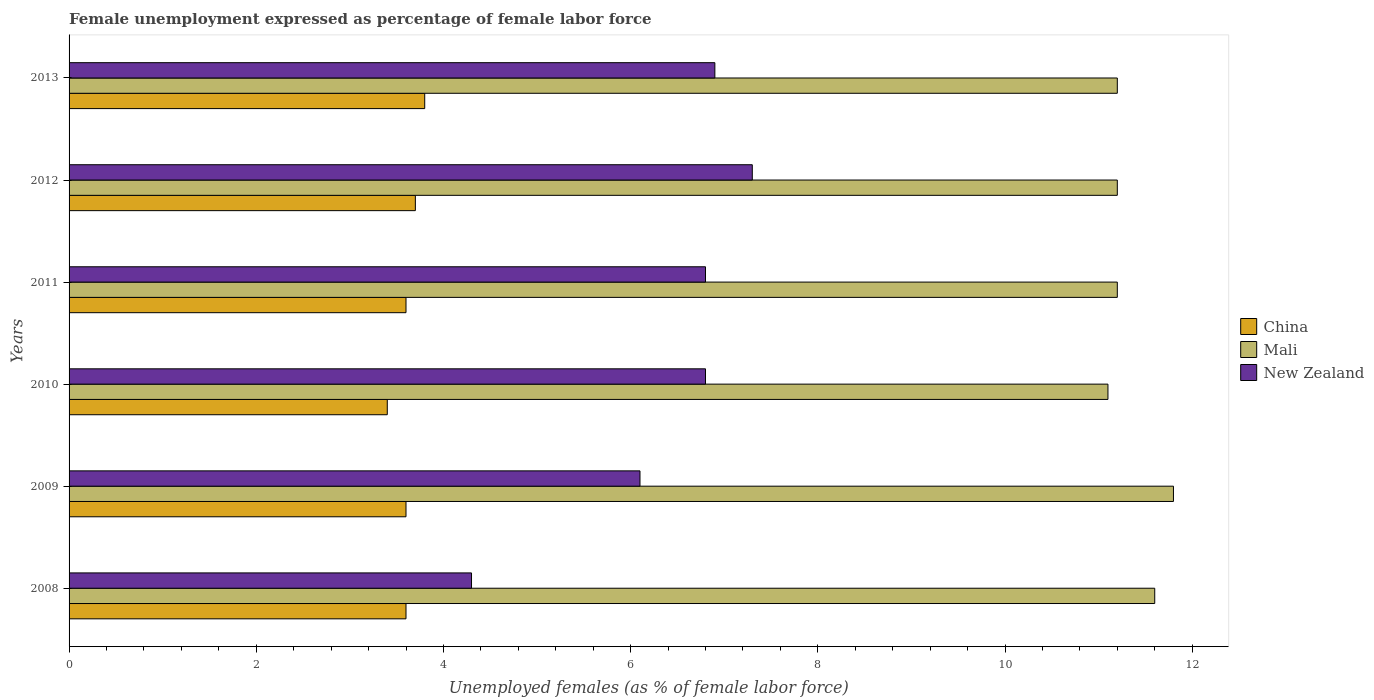Are the number of bars per tick equal to the number of legend labels?
Your answer should be compact. Yes. How many bars are there on the 2nd tick from the bottom?
Offer a very short reply. 3. What is the label of the 4th group of bars from the top?
Your response must be concise. 2010. In how many cases, is the number of bars for a given year not equal to the number of legend labels?
Keep it short and to the point. 0. What is the unemployment in females in in New Zealand in 2010?
Your answer should be very brief. 6.8. Across all years, what is the maximum unemployment in females in in China?
Provide a succinct answer. 3.8. Across all years, what is the minimum unemployment in females in in New Zealand?
Your answer should be compact. 4.3. In which year was the unemployment in females in in Mali minimum?
Provide a succinct answer. 2010. What is the total unemployment in females in in Mali in the graph?
Keep it short and to the point. 68.1. What is the difference between the unemployment in females in in China in 2012 and that in 2013?
Provide a short and direct response. -0.1. What is the difference between the unemployment in females in in New Zealand in 2010 and the unemployment in females in in China in 2013?
Ensure brevity in your answer.  3. What is the average unemployment in females in in China per year?
Give a very brief answer. 3.62. In the year 2012, what is the difference between the unemployment in females in in China and unemployment in females in in New Zealand?
Ensure brevity in your answer.  -3.6. What is the ratio of the unemployment in females in in Mali in 2009 to that in 2013?
Provide a short and direct response. 1.05. Is the difference between the unemployment in females in in China in 2010 and 2013 greater than the difference between the unemployment in females in in New Zealand in 2010 and 2013?
Make the answer very short. No. What is the difference between the highest and the second highest unemployment in females in in New Zealand?
Provide a short and direct response. 0.4. What is the difference between the highest and the lowest unemployment in females in in China?
Ensure brevity in your answer.  0.4. What does the 1st bar from the top in 2008 represents?
Your response must be concise. New Zealand. What does the 2nd bar from the bottom in 2011 represents?
Ensure brevity in your answer.  Mali. Are the values on the major ticks of X-axis written in scientific E-notation?
Give a very brief answer. No. Does the graph contain grids?
Make the answer very short. No. How many legend labels are there?
Your response must be concise. 3. What is the title of the graph?
Your response must be concise. Female unemployment expressed as percentage of female labor force. What is the label or title of the X-axis?
Give a very brief answer. Unemployed females (as % of female labor force). What is the Unemployed females (as % of female labor force) of China in 2008?
Give a very brief answer. 3.6. What is the Unemployed females (as % of female labor force) of Mali in 2008?
Offer a very short reply. 11.6. What is the Unemployed females (as % of female labor force) of New Zealand in 2008?
Offer a terse response. 4.3. What is the Unemployed females (as % of female labor force) of China in 2009?
Keep it short and to the point. 3.6. What is the Unemployed females (as % of female labor force) of Mali in 2009?
Give a very brief answer. 11.8. What is the Unemployed females (as % of female labor force) of New Zealand in 2009?
Keep it short and to the point. 6.1. What is the Unemployed females (as % of female labor force) in China in 2010?
Make the answer very short. 3.4. What is the Unemployed females (as % of female labor force) in Mali in 2010?
Offer a terse response. 11.1. What is the Unemployed females (as % of female labor force) in New Zealand in 2010?
Your answer should be compact. 6.8. What is the Unemployed females (as % of female labor force) in China in 2011?
Your answer should be compact. 3.6. What is the Unemployed females (as % of female labor force) in Mali in 2011?
Provide a short and direct response. 11.2. What is the Unemployed females (as % of female labor force) of New Zealand in 2011?
Provide a succinct answer. 6.8. What is the Unemployed females (as % of female labor force) in China in 2012?
Offer a terse response. 3.7. What is the Unemployed females (as % of female labor force) of Mali in 2012?
Your answer should be very brief. 11.2. What is the Unemployed females (as % of female labor force) in New Zealand in 2012?
Your response must be concise. 7.3. What is the Unemployed females (as % of female labor force) in China in 2013?
Provide a succinct answer. 3.8. What is the Unemployed females (as % of female labor force) of Mali in 2013?
Provide a succinct answer. 11.2. What is the Unemployed females (as % of female labor force) in New Zealand in 2013?
Offer a terse response. 6.9. Across all years, what is the maximum Unemployed females (as % of female labor force) in China?
Give a very brief answer. 3.8. Across all years, what is the maximum Unemployed females (as % of female labor force) of Mali?
Give a very brief answer. 11.8. Across all years, what is the maximum Unemployed females (as % of female labor force) in New Zealand?
Ensure brevity in your answer.  7.3. Across all years, what is the minimum Unemployed females (as % of female labor force) in China?
Provide a succinct answer. 3.4. Across all years, what is the minimum Unemployed females (as % of female labor force) of Mali?
Ensure brevity in your answer.  11.1. Across all years, what is the minimum Unemployed females (as % of female labor force) of New Zealand?
Ensure brevity in your answer.  4.3. What is the total Unemployed females (as % of female labor force) of China in the graph?
Your answer should be compact. 21.7. What is the total Unemployed females (as % of female labor force) of Mali in the graph?
Your response must be concise. 68.1. What is the total Unemployed females (as % of female labor force) of New Zealand in the graph?
Keep it short and to the point. 38.2. What is the difference between the Unemployed females (as % of female labor force) in New Zealand in 2008 and that in 2009?
Provide a succinct answer. -1.8. What is the difference between the Unemployed females (as % of female labor force) of China in 2008 and that in 2011?
Offer a terse response. 0. What is the difference between the Unemployed females (as % of female labor force) in China in 2008 and that in 2012?
Provide a succinct answer. -0.1. What is the difference between the Unemployed females (as % of female labor force) of Mali in 2008 and that in 2012?
Ensure brevity in your answer.  0.4. What is the difference between the Unemployed females (as % of female labor force) of China in 2008 and that in 2013?
Make the answer very short. -0.2. What is the difference between the Unemployed females (as % of female labor force) of Mali in 2008 and that in 2013?
Give a very brief answer. 0.4. What is the difference between the Unemployed females (as % of female labor force) in New Zealand in 2009 and that in 2010?
Your answer should be compact. -0.7. What is the difference between the Unemployed females (as % of female labor force) in Mali in 2009 and that in 2011?
Your response must be concise. 0.6. What is the difference between the Unemployed females (as % of female labor force) of China in 2009 and that in 2012?
Your answer should be compact. -0.1. What is the difference between the Unemployed females (as % of female labor force) in Mali in 2009 and that in 2012?
Provide a succinct answer. 0.6. What is the difference between the Unemployed females (as % of female labor force) in China in 2009 and that in 2013?
Make the answer very short. -0.2. What is the difference between the Unemployed females (as % of female labor force) in Mali in 2009 and that in 2013?
Make the answer very short. 0.6. What is the difference between the Unemployed females (as % of female labor force) in China in 2010 and that in 2011?
Keep it short and to the point. -0.2. What is the difference between the Unemployed females (as % of female labor force) of Mali in 2010 and that in 2011?
Give a very brief answer. -0.1. What is the difference between the Unemployed females (as % of female labor force) of Mali in 2010 and that in 2012?
Your answer should be very brief. -0.1. What is the difference between the Unemployed females (as % of female labor force) in New Zealand in 2010 and that in 2012?
Provide a short and direct response. -0.5. What is the difference between the Unemployed females (as % of female labor force) in New Zealand in 2010 and that in 2013?
Offer a terse response. -0.1. What is the difference between the Unemployed females (as % of female labor force) of China in 2011 and that in 2013?
Ensure brevity in your answer.  -0.2. What is the difference between the Unemployed females (as % of female labor force) in New Zealand in 2011 and that in 2013?
Your answer should be very brief. -0.1. What is the difference between the Unemployed females (as % of female labor force) of China in 2012 and that in 2013?
Provide a short and direct response. -0.1. What is the difference between the Unemployed females (as % of female labor force) of New Zealand in 2012 and that in 2013?
Your response must be concise. 0.4. What is the difference between the Unemployed females (as % of female labor force) in China in 2008 and the Unemployed females (as % of female labor force) in New Zealand in 2009?
Your answer should be very brief. -2.5. What is the difference between the Unemployed females (as % of female labor force) of Mali in 2008 and the Unemployed females (as % of female labor force) of New Zealand in 2009?
Keep it short and to the point. 5.5. What is the difference between the Unemployed females (as % of female labor force) of China in 2008 and the Unemployed females (as % of female labor force) of Mali in 2010?
Your response must be concise. -7.5. What is the difference between the Unemployed females (as % of female labor force) in Mali in 2008 and the Unemployed females (as % of female labor force) in New Zealand in 2010?
Your response must be concise. 4.8. What is the difference between the Unemployed females (as % of female labor force) of China in 2008 and the Unemployed females (as % of female labor force) of Mali in 2011?
Provide a succinct answer. -7.6. What is the difference between the Unemployed females (as % of female labor force) in China in 2008 and the Unemployed females (as % of female labor force) in New Zealand in 2011?
Your answer should be very brief. -3.2. What is the difference between the Unemployed females (as % of female labor force) of China in 2008 and the Unemployed females (as % of female labor force) of New Zealand in 2013?
Your answer should be very brief. -3.3. What is the difference between the Unemployed females (as % of female labor force) of Mali in 2008 and the Unemployed females (as % of female labor force) of New Zealand in 2013?
Your answer should be very brief. 4.7. What is the difference between the Unemployed females (as % of female labor force) in China in 2009 and the Unemployed females (as % of female labor force) in Mali in 2010?
Your response must be concise. -7.5. What is the difference between the Unemployed females (as % of female labor force) of China in 2009 and the Unemployed females (as % of female labor force) of Mali in 2011?
Keep it short and to the point. -7.6. What is the difference between the Unemployed females (as % of female labor force) of China in 2009 and the Unemployed females (as % of female labor force) of Mali in 2012?
Your answer should be compact. -7.6. What is the difference between the Unemployed females (as % of female labor force) of Mali in 2009 and the Unemployed females (as % of female labor force) of New Zealand in 2012?
Offer a very short reply. 4.5. What is the difference between the Unemployed females (as % of female labor force) of China in 2009 and the Unemployed females (as % of female labor force) of Mali in 2013?
Ensure brevity in your answer.  -7.6. What is the difference between the Unemployed females (as % of female labor force) of Mali in 2009 and the Unemployed females (as % of female labor force) of New Zealand in 2013?
Your answer should be very brief. 4.9. What is the difference between the Unemployed females (as % of female labor force) of China in 2010 and the Unemployed females (as % of female labor force) of Mali in 2011?
Your answer should be very brief. -7.8. What is the difference between the Unemployed females (as % of female labor force) in Mali in 2010 and the Unemployed females (as % of female labor force) in New Zealand in 2012?
Your response must be concise. 3.8. What is the difference between the Unemployed females (as % of female labor force) in Mali in 2010 and the Unemployed females (as % of female labor force) in New Zealand in 2013?
Give a very brief answer. 4.2. What is the difference between the Unemployed females (as % of female labor force) of China in 2011 and the Unemployed females (as % of female labor force) of New Zealand in 2012?
Offer a terse response. -3.7. What is the difference between the Unemployed females (as % of female labor force) of China in 2011 and the Unemployed females (as % of female labor force) of Mali in 2013?
Your response must be concise. -7.6. What is the difference between the Unemployed females (as % of female labor force) of China in 2011 and the Unemployed females (as % of female labor force) of New Zealand in 2013?
Offer a terse response. -3.3. What is the difference between the Unemployed females (as % of female labor force) in Mali in 2011 and the Unemployed females (as % of female labor force) in New Zealand in 2013?
Provide a short and direct response. 4.3. What is the average Unemployed females (as % of female labor force) in China per year?
Make the answer very short. 3.62. What is the average Unemployed females (as % of female labor force) in Mali per year?
Provide a succinct answer. 11.35. What is the average Unemployed females (as % of female labor force) in New Zealand per year?
Offer a terse response. 6.37. In the year 2008, what is the difference between the Unemployed females (as % of female labor force) of China and Unemployed females (as % of female labor force) of Mali?
Make the answer very short. -8. In the year 2008, what is the difference between the Unemployed females (as % of female labor force) of China and Unemployed females (as % of female labor force) of New Zealand?
Provide a succinct answer. -0.7. In the year 2009, what is the difference between the Unemployed females (as % of female labor force) of China and Unemployed females (as % of female labor force) of New Zealand?
Keep it short and to the point. -2.5. In the year 2009, what is the difference between the Unemployed females (as % of female labor force) in Mali and Unemployed females (as % of female labor force) in New Zealand?
Provide a short and direct response. 5.7. In the year 2010, what is the difference between the Unemployed females (as % of female labor force) in China and Unemployed females (as % of female labor force) in New Zealand?
Offer a very short reply. -3.4. In the year 2012, what is the difference between the Unemployed females (as % of female labor force) in Mali and Unemployed females (as % of female labor force) in New Zealand?
Offer a terse response. 3.9. In the year 2013, what is the difference between the Unemployed females (as % of female labor force) of China and Unemployed females (as % of female labor force) of Mali?
Your response must be concise. -7.4. In the year 2013, what is the difference between the Unemployed females (as % of female labor force) of China and Unemployed females (as % of female labor force) of New Zealand?
Offer a very short reply. -3.1. In the year 2013, what is the difference between the Unemployed females (as % of female labor force) in Mali and Unemployed females (as % of female labor force) in New Zealand?
Offer a terse response. 4.3. What is the ratio of the Unemployed females (as % of female labor force) in Mali in 2008 to that in 2009?
Your answer should be compact. 0.98. What is the ratio of the Unemployed females (as % of female labor force) of New Zealand in 2008 to that in 2009?
Provide a short and direct response. 0.7. What is the ratio of the Unemployed females (as % of female labor force) of China in 2008 to that in 2010?
Your response must be concise. 1.06. What is the ratio of the Unemployed females (as % of female labor force) in Mali in 2008 to that in 2010?
Ensure brevity in your answer.  1.04. What is the ratio of the Unemployed females (as % of female labor force) in New Zealand in 2008 to that in 2010?
Make the answer very short. 0.63. What is the ratio of the Unemployed females (as % of female labor force) of China in 2008 to that in 2011?
Your answer should be very brief. 1. What is the ratio of the Unemployed females (as % of female labor force) in Mali in 2008 to that in 2011?
Ensure brevity in your answer.  1.04. What is the ratio of the Unemployed females (as % of female labor force) in New Zealand in 2008 to that in 2011?
Ensure brevity in your answer.  0.63. What is the ratio of the Unemployed females (as % of female labor force) in Mali in 2008 to that in 2012?
Offer a terse response. 1.04. What is the ratio of the Unemployed females (as % of female labor force) in New Zealand in 2008 to that in 2012?
Provide a short and direct response. 0.59. What is the ratio of the Unemployed females (as % of female labor force) of China in 2008 to that in 2013?
Your answer should be very brief. 0.95. What is the ratio of the Unemployed females (as % of female labor force) of Mali in 2008 to that in 2013?
Provide a short and direct response. 1.04. What is the ratio of the Unemployed females (as % of female labor force) of New Zealand in 2008 to that in 2013?
Give a very brief answer. 0.62. What is the ratio of the Unemployed females (as % of female labor force) in China in 2009 to that in 2010?
Your answer should be very brief. 1.06. What is the ratio of the Unemployed females (as % of female labor force) in Mali in 2009 to that in 2010?
Offer a very short reply. 1.06. What is the ratio of the Unemployed females (as % of female labor force) of New Zealand in 2009 to that in 2010?
Your response must be concise. 0.9. What is the ratio of the Unemployed females (as % of female labor force) in Mali in 2009 to that in 2011?
Your answer should be very brief. 1.05. What is the ratio of the Unemployed females (as % of female labor force) of New Zealand in 2009 to that in 2011?
Your response must be concise. 0.9. What is the ratio of the Unemployed females (as % of female labor force) in China in 2009 to that in 2012?
Provide a succinct answer. 0.97. What is the ratio of the Unemployed females (as % of female labor force) in Mali in 2009 to that in 2012?
Ensure brevity in your answer.  1.05. What is the ratio of the Unemployed females (as % of female labor force) of New Zealand in 2009 to that in 2012?
Offer a very short reply. 0.84. What is the ratio of the Unemployed females (as % of female labor force) of Mali in 2009 to that in 2013?
Keep it short and to the point. 1.05. What is the ratio of the Unemployed females (as % of female labor force) in New Zealand in 2009 to that in 2013?
Your answer should be very brief. 0.88. What is the ratio of the Unemployed females (as % of female labor force) in New Zealand in 2010 to that in 2011?
Your answer should be very brief. 1. What is the ratio of the Unemployed females (as % of female labor force) in China in 2010 to that in 2012?
Your response must be concise. 0.92. What is the ratio of the Unemployed females (as % of female labor force) of Mali in 2010 to that in 2012?
Your answer should be very brief. 0.99. What is the ratio of the Unemployed females (as % of female labor force) of New Zealand in 2010 to that in 2012?
Offer a very short reply. 0.93. What is the ratio of the Unemployed females (as % of female labor force) of China in 2010 to that in 2013?
Offer a very short reply. 0.89. What is the ratio of the Unemployed females (as % of female labor force) of Mali in 2010 to that in 2013?
Provide a succinct answer. 0.99. What is the ratio of the Unemployed females (as % of female labor force) of New Zealand in 2010 to that in 2013?
Your answer should be very brief. 0.99. What is the ratio of the Unemployed females (as % of female labor force) of New Zealand in 2011 to that in 2012?
Provide a succinct answer. 0.93. What is the ratio of the Unemployed females (as % of female labor force) of China in 2011 to that in 2013?
Provide a short and direct response. 0.95. What is the ratio of the Unemployed females (as % of female labor force) of New Zealand in 2011 to that in 2013?
Offer a terse response. 0.99. What is the ratio of the Unemployed females (as % of female labor force) of China in 2012 to that in 2013?
Offer a terse response. 0.97. What is the ratio of the Unemployed females (as % of female labor force) in Mali in 2012 to that in 2013?
Provide a succinct answer. 1. What is the ratio of the Unemployed females (as % of female labor force) of New Zealand in 2012 to that in 2013?
Your answer should be very brief. 1.06. What is the difference between the highest and the second highest Unemployed females (as % of female labor force) in Mali?
Offer a very short reply. 0.2. What is the difference between the highest and the second highest Unemployed females (as % of female labor force) in New Zealand?
Provide a short and direct response. 0.4. What is the difference between the highest and the lowest Unemployed females (as % of female labor force) in China?
Offer a terse response. 0.4. What is the difference between the highest and the lowest Unemployed females (as % of female labor force) in New Zealand?
Your response must be concise. 3. 